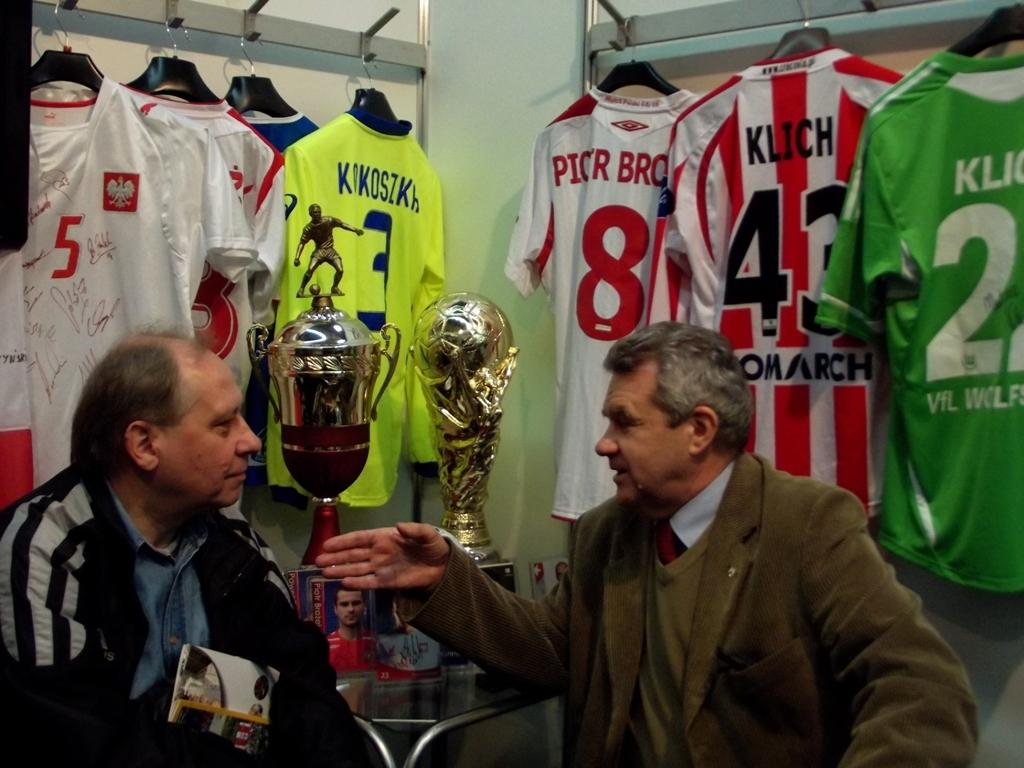Provide a one-sentence caption for the provided image. Klich number 43 is on the back of the red and white striped jersey hanging on the wall. 